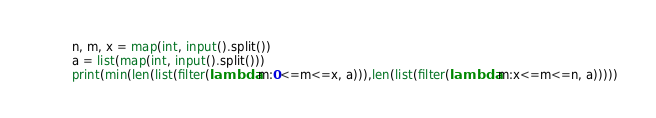<code> <loc_0><loc_0><loc_500><loc_500><_Python_>n, m, x = map(int, input().split())
a = list(map(int, input().split()))
print(min(len(list(filter(lambda m:0<=m<=x, a))),len(list(filter(lambda m:x<=m<=n, a)))))</code> 